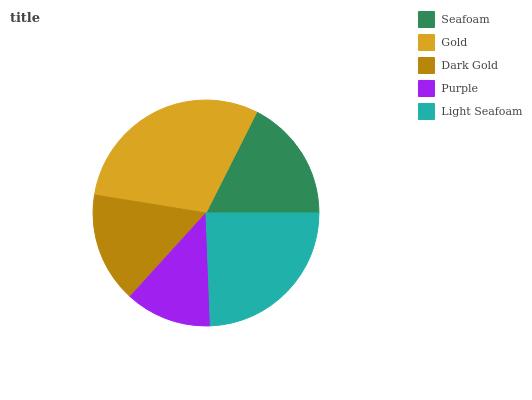Is Purple the minimum?
Answer yes or no. Yes. Is Gold the maximum?
Answer yes or no. Yes. Is Dark Gold the minimum?
Answer yes or no. No. Is Dark Gold the maximum?
Answer yes or no. No. Is Gold greater than Dark Gold?
Answer yes or no. Yes. Is Dark Gold less than Gold?
Answer yes or no. Yes. Is Dark Gold greater than Gold?
Answer yes or no. No. Is Gold less than Dark Gold?
Answer yes or no. No. Is Seafoam the high median?
Answer yes or no. Yes. Is Seafoam the low median?
Answer yes or no. Yes. Is Light Seafoam the high median?
Answer yes or no. No. Is Light Seafoam the low median?
Answer yes or no. No. 